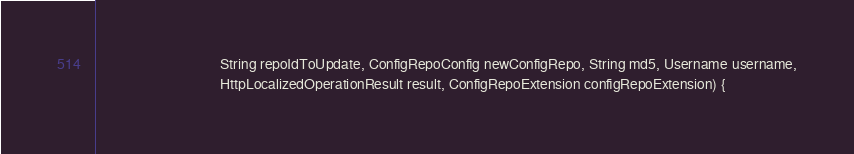Convert code to text. <code><loc_0><loc_0><loc_500><loc_500><_Java_>                                   String repoIdToUpdate, ConfigRepoConfig newConfigRepo, String md5, Username username,
                                   HttpLocalizedOperationResult result, ConfigRepoExtension configRepoExtension) {</code> 